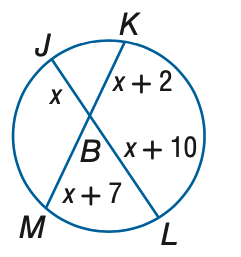Question: Find x to the nearest tenth. Assume that segments that appear to be tangent are tangent.
Choices:
A. 14
B. 16
C. 18
D. 20
Answer with the letter. Answer: A 